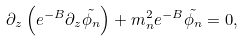Convert formula to latex. <formula><loc_0><loc_0><loc_500><loc_500>\partial _ { z } \left ( e ^ { - B } \partial _ { z } \tilde { \phi _ { n } } \right ) + m _ { n } ^ { 2 } e ^ { - B } \tilde { \phi _ { n } } = 0 ,</formula> 